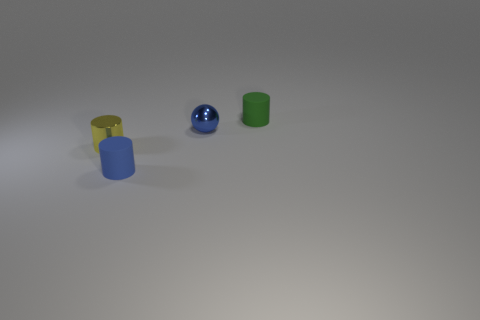Does the tiny blue matte thing have the same shape as the tiny metallic object to the left of the blue metal thing?
Make the answer very short. Yes. What color is the cylinder to the right of the tiny rubber object that is on the left side of the tiny cylinder that is to the right of the ball?
Your answer should be compact. Green. How many things are either tiny cylinders that are on the right side of the tiny metal sphere or green things behind the yellow thing?
Provide a short and direct response. 1. What number of other objects are the same color as the tiny metal ball?
Offer a very short reply. 1. There is a small matte thing in front of the tiny yellow metallic cylinder; is it the same shape as the yellow metallic thing?
Offer a very short reply. Yes. Are there fewer spheres that are to the left of the blue cylinder than small metallic cylinders?
Your answer should be compact. Yes. Is there a tiny thing made of the same material as the tiny blue ball?
Give a very brief answer. Yes. There is a sphere that is the same size as the yellow metallic thing; what material is it?
Your answer should be compact. Metal. Is the number of small objects to the right of the small green thing less than the number of metal balls on the left side of the tiny blue matte cylinder?
Give a very brief answer. No. The thing that is both left of the blue metal thing and on the right side of the yellow object has what shape?
Make the answer very short. Cylinder. 